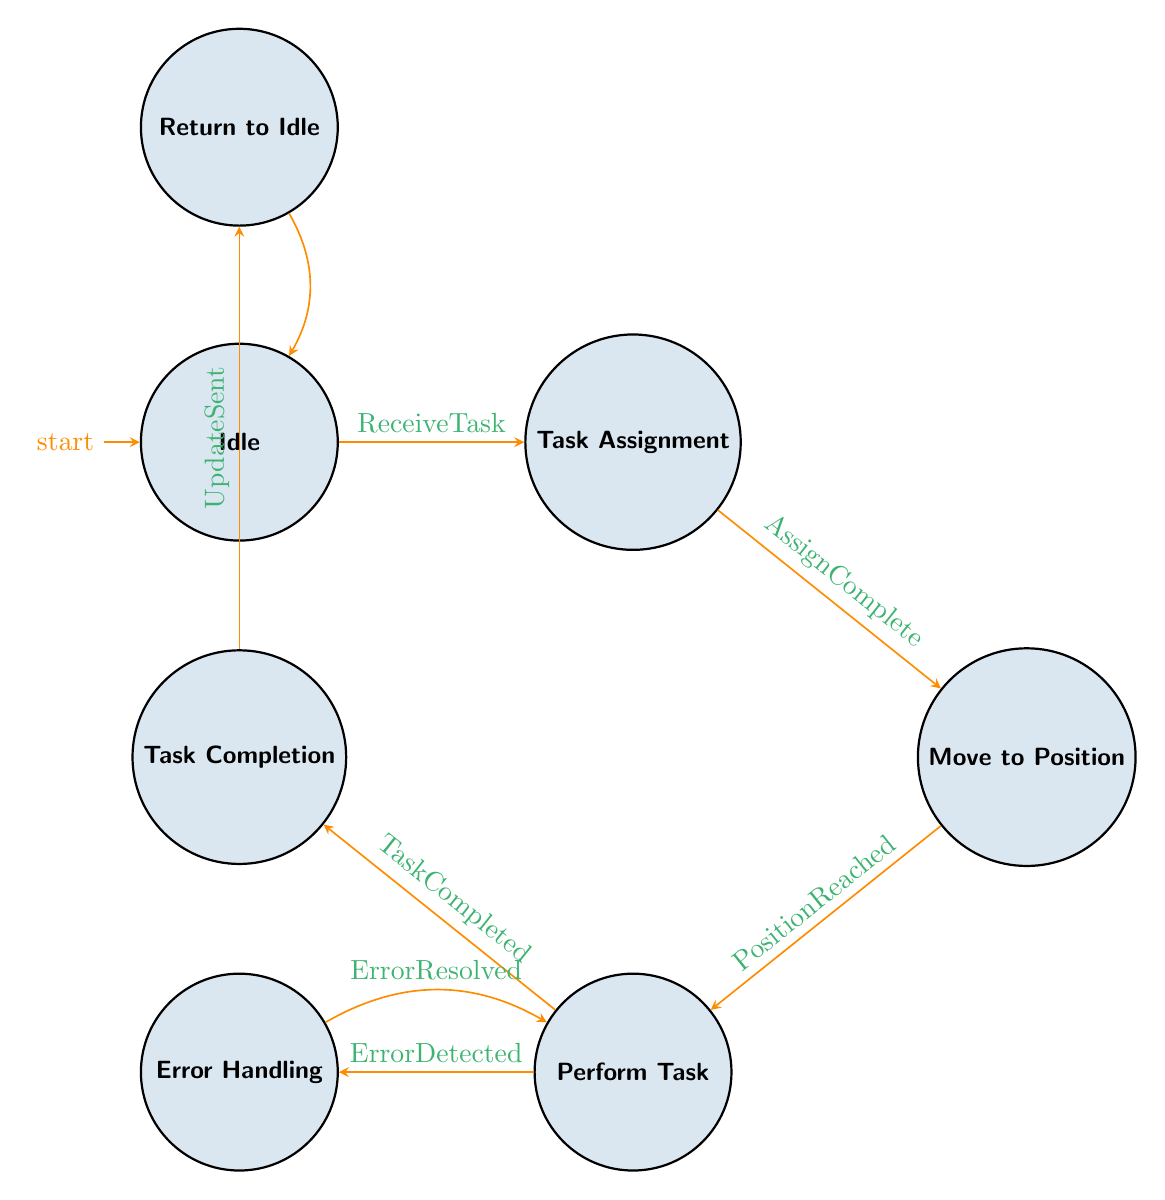What is the initial state of the robot? The diagram indicates that the initial state is marked with an arrow pointing to "Idle," suggesting that this is where the robot begins its operation.
Answer: Idle How many states are present in the diagram? By counting each unique state node shown in the diagram, there are a total of seven states: Idle, Task Assignment, Move to Position, Perform Task, Error Handling, Task Completion, and Return to Idle.
Answer: Seven What is the transition condition from "Idle" to "Task Assignment"? The arrow between "Idle" and "Task Assignment" is labeled with the transition condition "ReceiveTask," which indicates that the robot moves to the next state upon receiving a task.
Answer: ReceiveTask Which state does the robot transition to after completing a task? According to the diagram, after the "Perform Task" state, the robot can transition to either "Error Handling" if an error is detected or to "Task Completion" if the task is finished, but specifically finishing the task leads to "Task Completion."
Answer: Task Completion What happens if an error is detected during task execution? If an error is detected, the transition from "Perform Task" to "Error Handling" occurs due to the condition "ErrorDetected," which indicates that the robot must address the error before proceeding.
Answer: Move to Error Handling How does the robot return to idle mode? After the "Task Completion" state, the robot transitions back to "Return to Idle," which is triggered by the condition "UpdateSent." This signifies that completion status has been sent, allowing the robot to reset to standby.
Answer: Return to Idle What is the last state before the robot goes back to Idle? The last state the robot goes to before returning to "Idle" is "Return to Idle," indicating the robot prepares itself for the next task after completing its current duties.
Answer: Return to Idle What condition must be satisfied for transitioning from "Error Handling" back to "Perform Task"? The transition from "Error Handling" back to "Perform Task" occurs when the condition "ErrorResolved" is met, indicating that the robot has addressed and corrected the error previously encountered.
Answer: ErrorResolved 